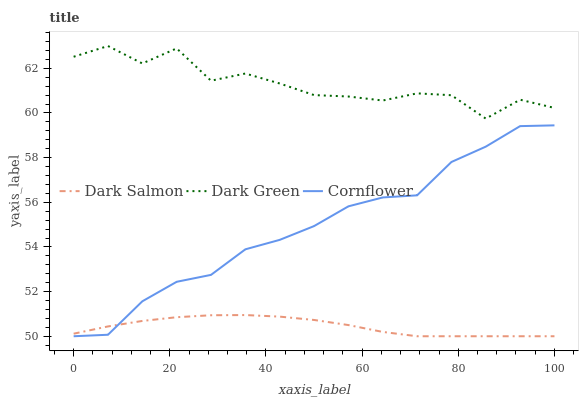Does Dark Salmon have the minimum area under the curve?
Answer yes or no. Yes. Does Dark Green have the maximum area under the curve?
Answer yes or no. Yes. Does Dark Green have the minimum area under the curve?
Answer yes or no. No. Does Dark Salmon have the maximum area under the curve?
Answer yes or no. No. Is Dark Salmon the smoothest?
Answer yes or no. Yes. Is Dark Green the roughest?
Answer yes or no. Yes. Is Dark Green the smoothest?
Answer yes or no. No. Is Dark Salmon the roughest?
Answer yes or no. No. Does Cornflower have the lowest value?
Answer yes or no. Yes. Does Dark Green have the lowest value?
Answer yes or no. No. Does Dark Green have the highest value?
Answer yes or no. Yes. Does Dark Salmon have the highest value?
Answer yes or no. No. Is Cornflower less than Dark Green?
Answer yes or no. Yes. Is Dark Green greater than Cornflower?
Answer yes or no. Yes. Does Cornflower intersect Dark Salmon?
Answer yes or no. Yes. Is Cornflower less than Dark Salmon?
Answer yes or no. No. Is Cornflower greater than Dark Salmon?
Answer yes or no. No. Does Cornflower intersect Dark Green?
Answer yes or no. No. 